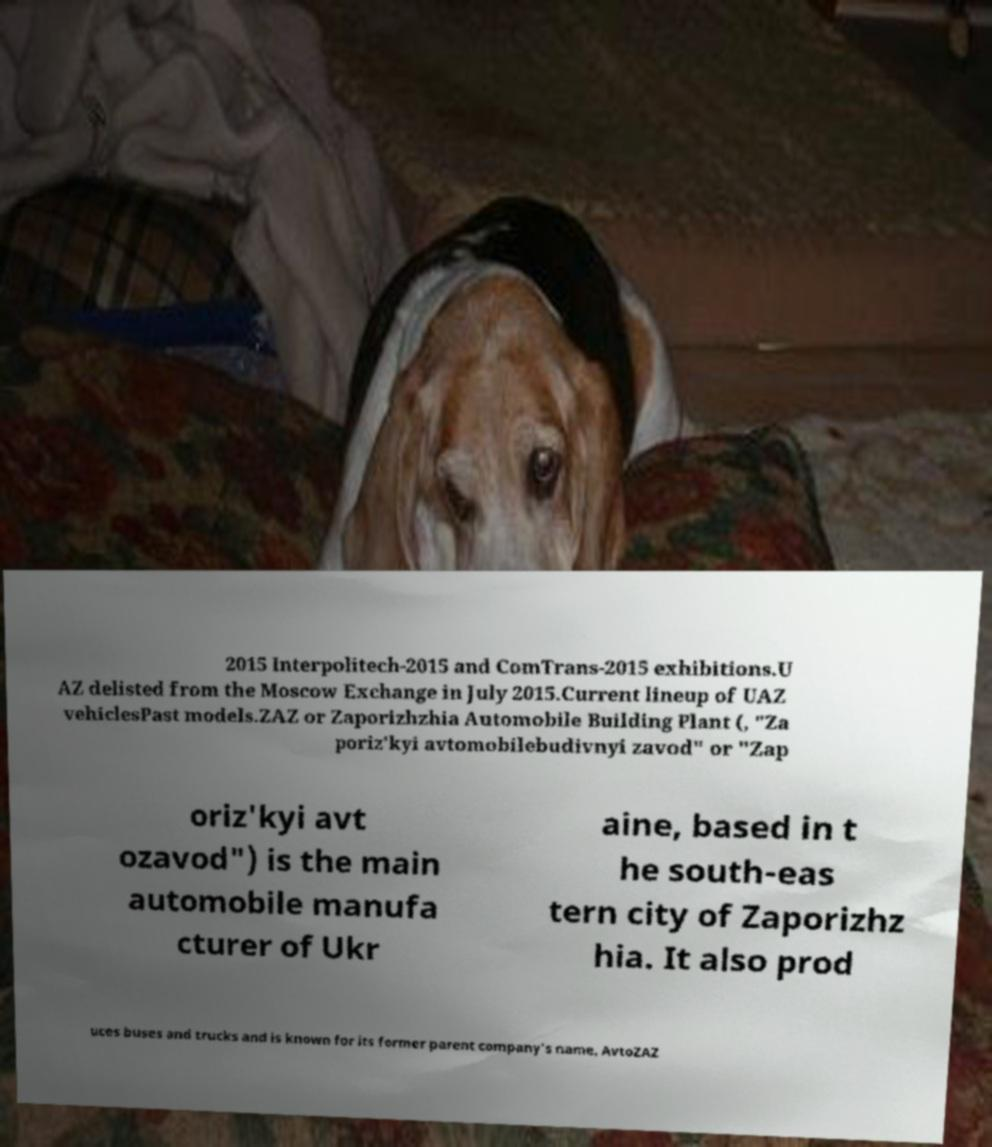For documentation purposes, I need the text within this image transcribed. Could you provide that? 2015 Interpolitech-2015 and ComTrans-2015 exhibitions.U AZ delisted from the Moscow Exchange in July 2015.Current lineup of UAZ vehiclesPast models.ZAZ or Zaporizhzhia Automobile Building Plant (, "Za poriz'kyi avtomobilebudivnyi zavod" or "Zap oriz'kyi avt ozavod") is the main automobile manufa cturer of Ukr aine, based in t he south-eas tern city of Zaporizhz hia. It also prod uces buses and trucks and is known for its former parent company's name, AvtoZAZ 